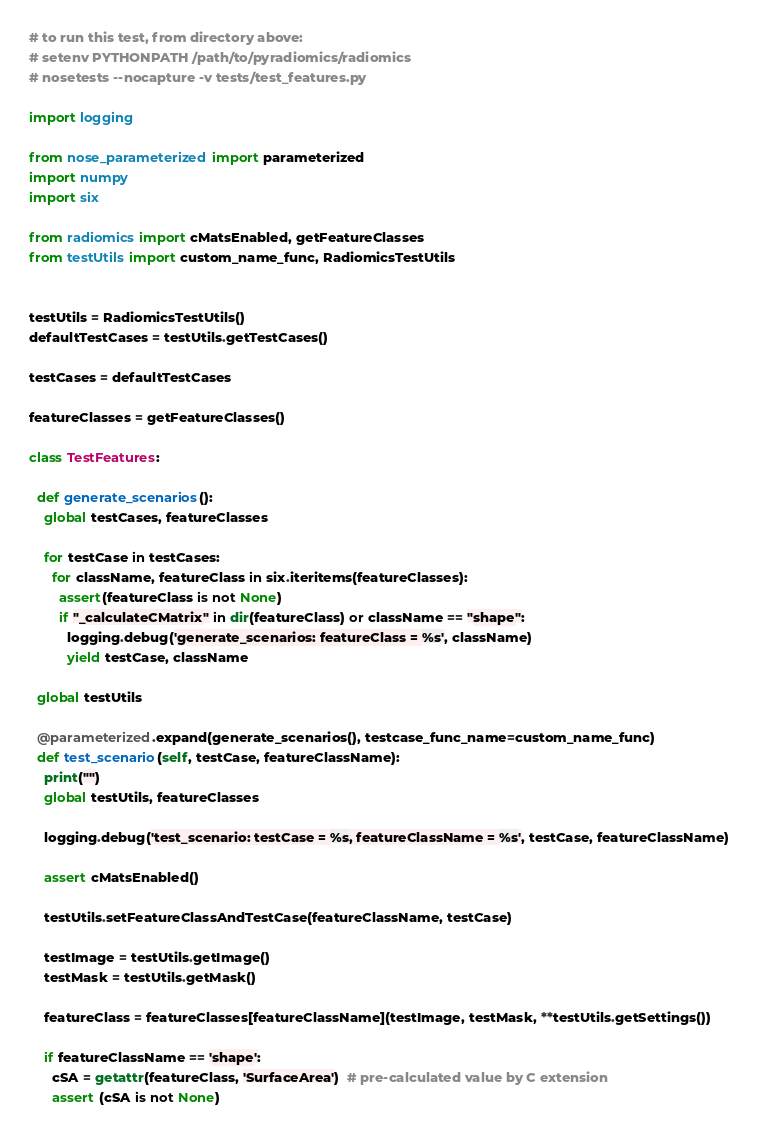<code> <loc_0><loc_0><loc_500><loc_500><_Python_># to run this test, from directory above:
# setenv PYTHONPATH /path/to/pyradiomics/radiomics
# nosetests --nocapture -v tests/test_features.py

import logging

from nose_parameterized import parameterized
import numpy
import six

from radiomics import cMatsEnabled, getFeatureClasses
from testUtils import custom_name_func, RadiomicsTestUtils


testUtils = RadiomicsTestUtils()
defaultTestCases = testUtils.getTestCases()

testCases = defaultTestCases

featureClasses = getFeatureClasses()

class TestFeatures:

  def generate_scenarios():
    global testCases, featureClasses

    for testCase in testCases:
      for className, featureClass in six.iteritems(featureClasses):
        assert(featureClass is not None)
        if "_calculateCMatrix" in dir(featureClass) or className == "shape":
          logging.debug('generate_scenarios: featureClass = %s', className)
          yield testCase, className

  global testUtils

  @parameterized.expand(generate_scenarios(), testcase_func_name=custom_name_func)
  def test_scenario(self, testCase, featureClassName):
    print("")
    global testUtils, featureClasses

    logging.debug('test_scenario: testCase = %s, featureClassName = %s', testCase, featureClassName)

    assert cMatsEnabled()

    testUtils.setFeatureClassAndTestCase(featureClassName, testCase)

    testImage = testUtils.getImage()
    testMask = testUtils.getMask()

    featureClass = featureClasses[featureClassName](testImage, testMask, **testUtils.getSettings())

    if featureClassName == 'shape':
      cSA = getattr(featureClass, 'SurfaceArea')  # pre-calculated value by C extension
      assert (cSA is not None)
</code> 